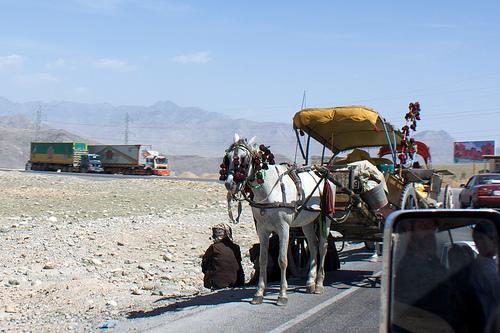How many trucks?
Give a very brief answer. 2. 